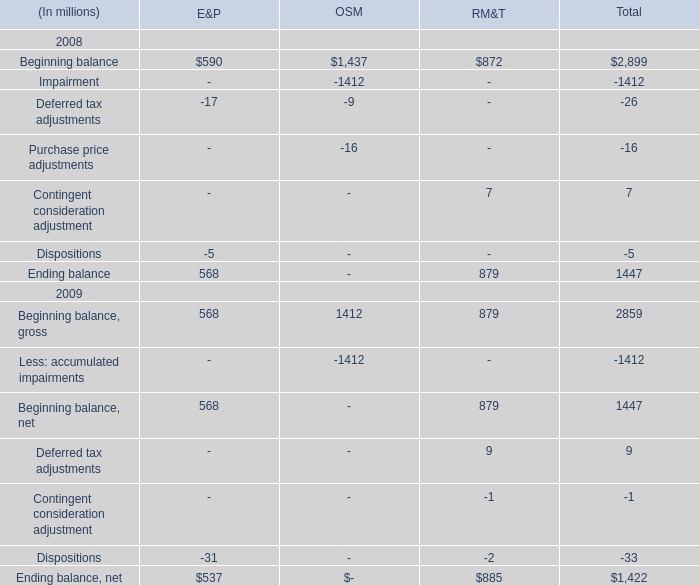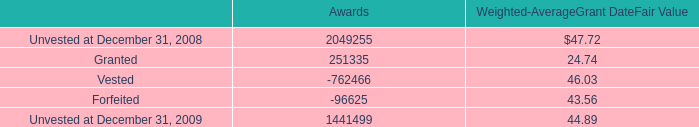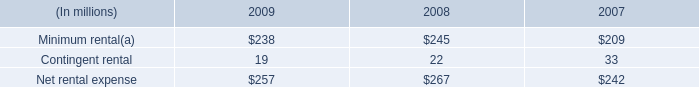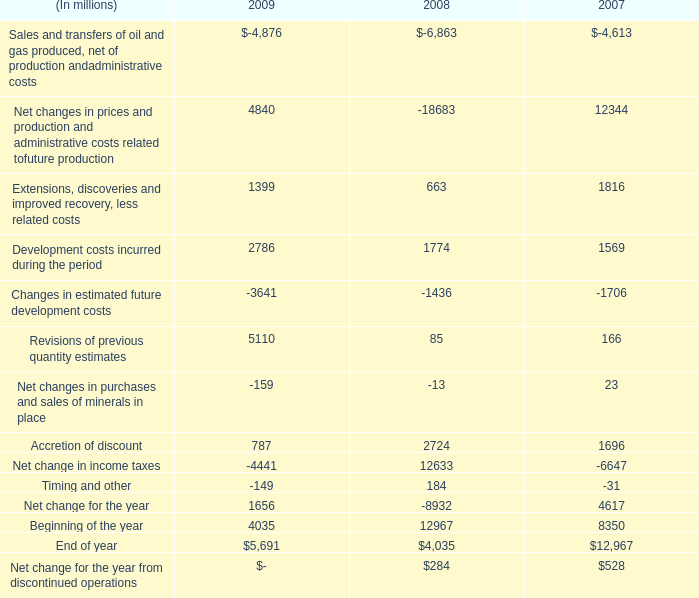what's the total amount of Unvested at December 31, 2009 of Awards, Beginning balance of OSM, and Extensions, discoveries and improved recovery, less related costs of 2007 ? 
Computations: ((1441499.0 + 1437.0) + 1816.0)
Answer: 1444752.0. 